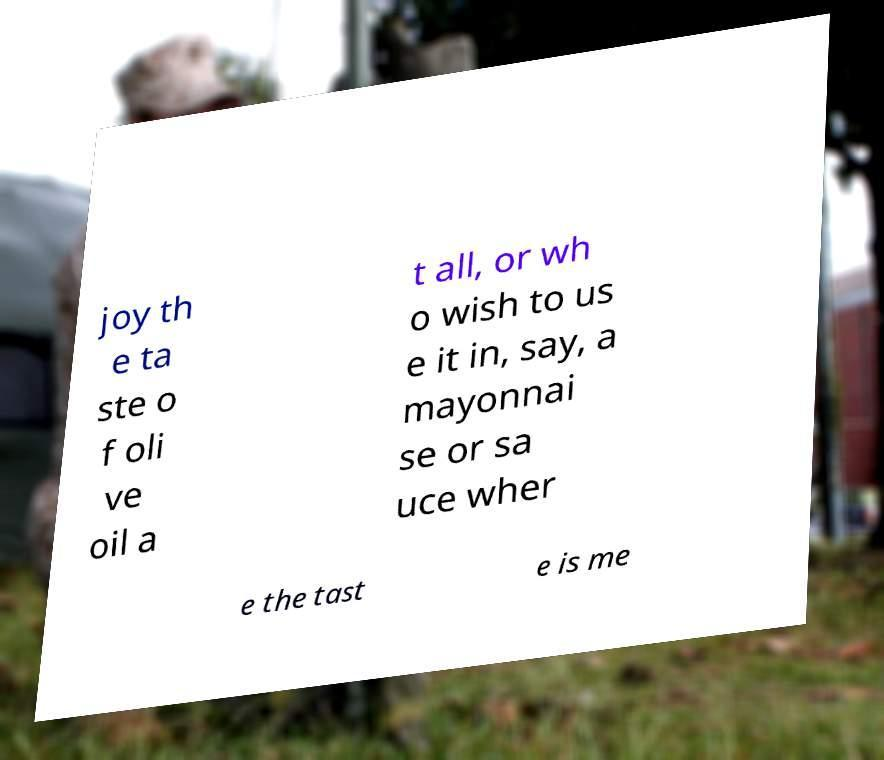There's text embedded in this image that I need extracted. Can you transcribe it verbatim? joy th e ta ste o f oli ve oil a t all, or wh o wish to us e it in, say, a mayonnai se or sa uce wher e the tast e is me 